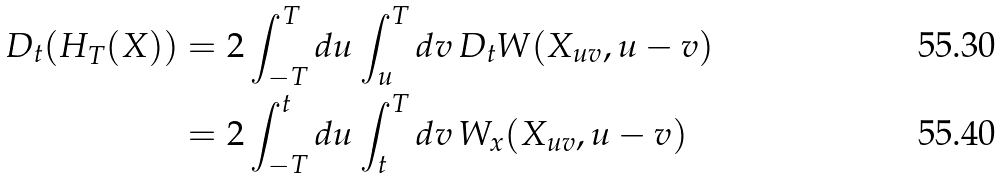<formula> <loc_0><loc_0><loc_500><loc_500>D _ { t } ( H _ { T } ( X ) ) & = 2 \int _ { - T } ^ { T } d u \int _ { u } ^ { T } d v \, D _ { t } W ( X _ { u v } , u - v ) \\ & = 2 \int _ { - T } ^ { t } d u \int _ { t } ^ { T } d v \, W _ { x } ( X _ { u v } , u - v )</formula> 